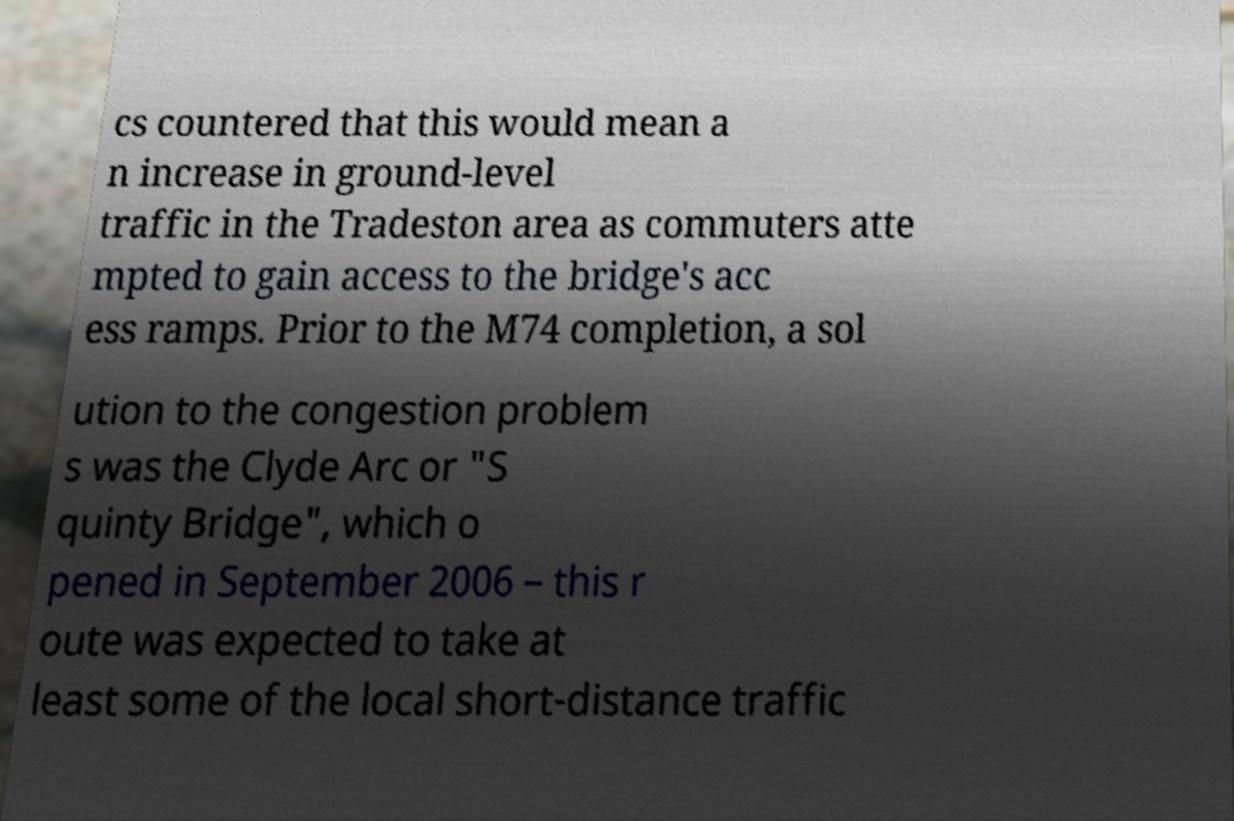I need the written content from this picture converted into text. Can you do that? cs countered that this would mean a n increase in ground-level traffic in the Tradeston area as commuters atte mpted to gain access to the bridge's acc ess ramps. Prior to the M74 completion, a sol ution to the congestion problem s was the Clyde Arc or "S quinty Bridge", which o pened in September 2006 – this r oute was expected to take at least some of the local short-distance traffic 